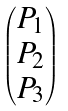<formula> <loc_0><loc_0><loc_500><loc_500>\begin{pmatrix} P _ { 1 } \\ P _ { 2 } \\ P _ { 3 } \end{pmatrix}</formula> 